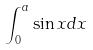<formula> <loc_0><loc_0><loc_500><loc_500>\int _ { 0 } ^ { a } \sin x d x</formula> 